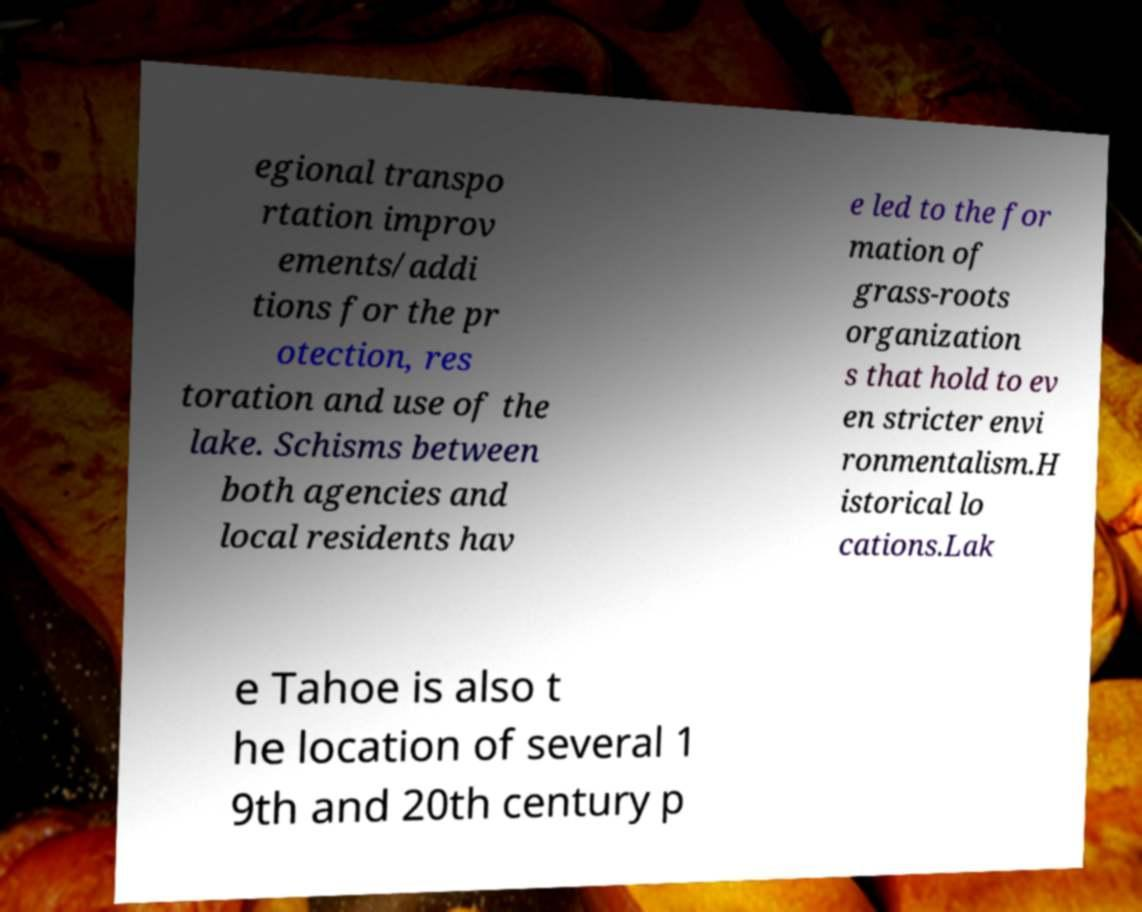Could you extract and type out the text from this image? egional transpo rtation improv ements/addi tions for the pr otection, res toration and use of the lake. Schisms between both agencies and local residents hav e led to the for mation of grass-roots organization s that hold to ev en stricter envi ronmentalism.H istorical lo cations.Lak e Tahoe is also t he location of several 1 9th and 20th century p 